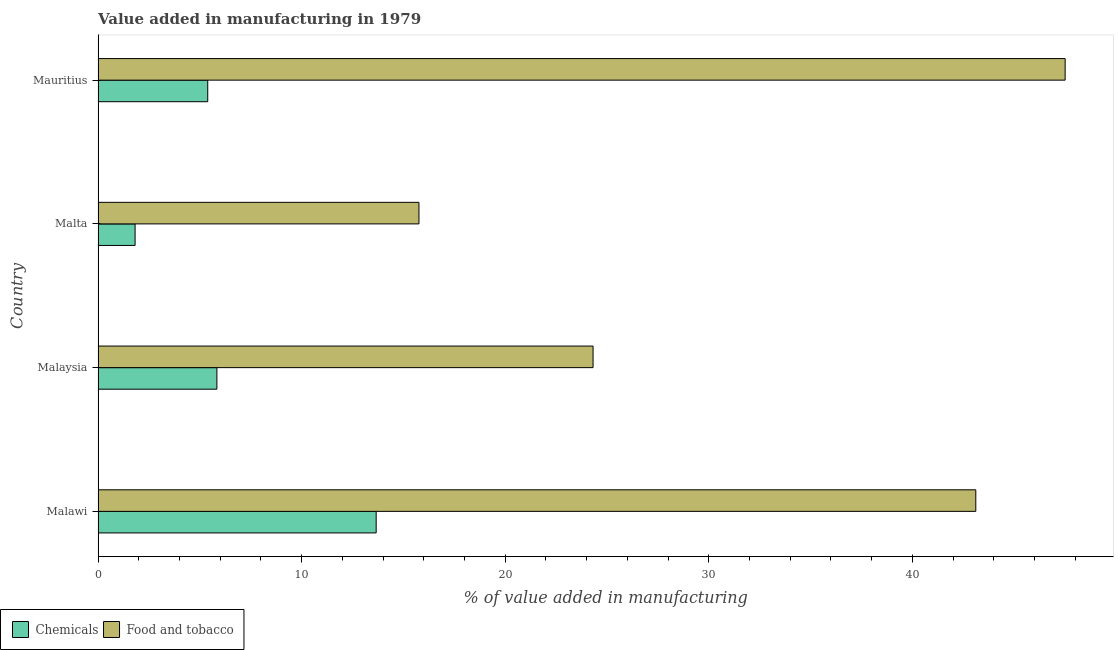How many groups of bars are there?
Make the answer very short. 4. What is the label of the 1st group of bars from the top?
Your answer should be very brief. Mauritius. In how many cases, is the number of bars for a given country not equal to the number of legend labels?
Make the answer very short. 0. What is the value added by  manufacturing chemicals in Malawi?
Provide a short and direct response. 13.66. Across all countries, what is the maximum value added by  manufacturing chemicals?
Offer a terse response. 13.66. Across all countries, what is the minimum value added by  manufacturing chemicals?
Make the answer very short. 1.82. In which country was the value added by  manufacturing chemicals maximum?
Keep it short and to the point. Malawi. In which country was the value added by manufacturing food and tobacco minimum?
Your response must be concise. Malta. What is the total value added by  manufacturing chemicals in the graph?
Offer a very short reply. 26.71. What is the difference between the value added by manufacturing food and tobacco in Malta and that in Mauritius?
Offer a very short reply. -31.74. What is the difference between the value added by manufacturing food and tobacco in Malta and the value added by  manufacturing chemicals in Mauritius?
Offer a terse response. 10.38. What is the average value added by manufacturing food and tobacco per country?
Give a very brief answer. 32.67. What is the difference between the value added by  manufacturing chemicals and value added by manufacturing food and tobacco in Malta?
Provide a succinct answer. -13.94. What is the ratio of the value added by manufacturing food and tobacco in Malaysia to that in Malta?
Keep it short and to the point. 1.54. What is the difference between the highest and the second highest value added by manufacturing food and tobacco?
Offer a very short reply. 4.39. What is the difference between the highest and the lowest value added by  manufacturing chemicals?
Offer a very short reply. 11.84. In how many countries, is the value added by manufacturing food and tobacco greater than the average value added by manufacturing food and tobacco taken over all countries?
Your answer should be very brief. 2. What does the 2nd bar from the top in Malta represents?
Your response must be concise. Chemicals. What does the 2nd bar from the bottom in Malawi represents?
Give a very brief answer. Food and tobacco. How many bars are there?
Your answer should be compact. 8. What is the difference between two consecutive major ticks on the X-axis?
Your response must be concise. 10. Does the graph contain any zero values?
Offer a terse response. No. Does the graph contain grids?
Make the answer very short. No. How are the legend labels stacked?
Provide a short and direct response. Horizontal. What is the title of the graph?
Keep it short and to the point. Value added in manufacturing in 1979. Does "Young" appear as one of the legend labels in the graph?
Your answer should be very brief. No. What is the label or title of the X-axis?
Your answer should be compact. % of value added in manufacturing. What is the label or title of the Y-axis?
Your response must be concise. Country. What is the % of value added in manufacturing of Chemicals in Malawi?
Your answer should be very brief. 13.66. What is the % of value added in manufacturing in Food and tobacco in Malawi?
Provide a short and direct response. 43.12. What is the % of value added in manufacturing of Chemicals in Malaysia?
Keep it short and to the point. 5.84. What is the % of value added in manufacturing in Food and tobacco in Malaysia?
Give a very brief answer. 24.32. What is the % of value added in manufacturing in Chemicals in Malta?
Your response must be concise. 1.82. What is the % of value added in manufacturing of Food and tobacco in Malta?
Your answer should be compact. 15.76. What is the % of value added in manufacturing in Chemicals in Mauritius?
Your response must be concise. 5.39. What is the % of value added in manufacturing of Food and tobacco in Mauritius?
Your answer should be compact. 47.5. Across all countries, what is the maximum % of value added in manufacturing in Chemicals?
Offer a very short reply. 13.66. Across all countries, what is the maximum % of value added in manufacturing of Food and tobacco?
Your response must be concise. 47.5. Across all countries, what is the minimum % of value added in manufacturing in Chemicals?
Ensure brevity in your answer.  1.82. Across all countries, what is the minimum % of value added in manufacturing of Food and tobacco?
Your answer should be very brief. 15.76. What is the total % of value added in manufacturing of Chemicals in the graph?
Your answer should be compact. 26.71. What is the total % of value added in manufacturing in Food and tobacco in the graph?
Provide a succinct answer. 130.7. What is the difference between the % of value added in manufacturing in Chemicals in Malawi and that in Malaysia?
Provide a short and direct response. 7.82. What is the difference between the % of value added in manufacturing of Food and tobacco in Malawi and that in Malaysia?
Keep it short and to the point. 18.8. What is the difference between the % of value added in manufacturing of Chemicals in Malawi and that in Malta?
Offer a terse response. 11.84. What is the difference between the % of value added in manufacturing of Food and tobacco in Malawi and that in Malta?
Provide a succinct answer. 27.35. What is the difference between the % of value added in manufacturing of Chemicals in Malawi and that in Mauritius?
Give a very brief answer. 8.27. What is the difference between the % of value added in manufacturing in Food and tobacco in Malawi and that in Mauritius?
Your answer should be compact. -4.39. What is the difference between the % of value added in manufacturing in Chemicals in Malaysia and that in Malta?
Give a very brief answer. 4.02. What is the difference between the % of value added in manufacturing in Food and tobacco in Malaysia and that in Malta?
Provide a succinct answer. 8.55. What is the difference between the % of value added in manufacturing of Chemicals in Malaysia and that in Mauritius?
Make the answer very short. 0.45. What is the difference between the % of value added in manufacturing of Food and tobacco in Malaysia and that in Mauritius?
Ensure brevity in your answer.  -23.19. What is the difference between the % of value added in manufacturing of Chemicals in Malta and that in Mauritius?
Make the answer very short. -3.57. What is the difference between the % of value added in manufacturing in Food and tobacco in Malta and that in Mauritius?
Offer a very short reply. -31.74. What is the difference between the % of value added in manufacturing in Chemicals in Malawi and the % of value added in manufacturing in Food and tobacco in Malaysia?
Offer a very short reply. -10.65. What is the difference between the % of value added in manufacturing in Chemicals in Malawi and the % of value added in manufacturing in Food and tobacco in Malta?
Your answer should be very brief. -2.1. What is the difference between the % of value added in manufacturing in Chemicals in Malawi and the % of value added in manufacturing in Food and tobacco in Mauritius?
Your answer should be very brief. -33.84. What is the difference between the % of value added in manufacturing in Chemicals in Malaysia and the % of value added in manufacturing in Food and tobacco in Malta?
Your response must be concise. -9.93. What is the difference between the % of value added in manufacturing of Chemicals in Malaysia and the % of value added in manufacturing of Food and tobacco in Mauritius?
Provide a succinct answer. -41.67. What is the difference between the % of value added in manufacturing of Chemicals in Malta and the % of value added in manufacturing of Food and tobacco in Mauritius?
Keep it short and to the point. -45.68. What is the average % of value added in manufacturing in Chemicals per country?
Keep it short and to the point. 6.68. What is the average % of value added in manufacturing in Food and tobacco per country?
Give a very brief answer. 32.67. What is the difference between the % of value added in manufacturing of Chemicals and % of value added in manufacturing of Food and tobacco in Malawi?
Make the answer very short. -29.45. What is the difference between the % of value added in manufacturing of Chemicals and % of value added in manufacturing of Food and tobacco in Malaysia?
Your response must be concise. -18.48. What is the difference between the % of value added in manufacturing in Chemicals and % of value added in manufacturing in Food and tobacco in Malta?
Offer a very short reply. -13.94. What is the difference between the % of value added in manufacturing in Chemicals and % of value added in manufacturing in Food and tobacco in Mauritius?
Keep it short and to the point. -42.12. What is the ratio of the % of value added in manufacturing of Chemicals in Malawi to that in Malaysia?
Make the answer very short. 2.34. What is the ratio of the % of value added in manufacturing in Food and tobacco in Malawi to that in Malaysia?
Your answer should be very brief. 1.77. What is the ratio of the % of value added in manufacturing of Chemicals in Malawi to that in Malta?
Ensure brevity in your answer.  7.51. What is the ratio of the % of value added in manufacturing of Food and tobacco in Malawi to that in Malta?
Your answer should be very brief. 2.74. What is the ratio of the % of value added in manufacturing of Chemicals in Malawi to that in Mauritius?
Give a very brief answer. 2.54. What is the ratio of the % of value added in manufacturing of Food and tobacco in Malawi to that in Mauritius?
Offer a terse response. 0.91. What is the ratio of the % of value added in manufacturing of Chemicals in Malaysia to that in Malta?
Offer a very short reply. 3.21. What is the ratio of the % of value added in manufacturing in Food and tobacco in Malaysia to that in Malta?
Offer a terse response. 1.54. What is the ratio of the % of value added in manufacturing in Chemicals in Malaysia to that in Mauritius?
Provide a short and direct response. 1.08. What is the ratio of the % of value added in manufacturing of Food and tobacco in Malaysia to that in Mauritius?
Make the answer very short. 0.51. What is the ratio of the % of value added in manufacturing in Chemicals in Malta to that in Mauritius?
Provide a short and direct response. 0.34. What is the ratio of the % of value added in manufacturing in Food and tobacco in Malta to that in Mauritius?
Offer a terse response. 0.33. What is the difference between the highest and the second highest % of value added in manufacturing in Chemicals?
Give a very brief answer. 7.82. What is the difference between the highest and the second highest % of value added in manufacturing of Food and tobacco?
Ensure brevity in your answer.  4.39. What is the difference between the highest and the lowest % of value added in manufacturing in Chemicals?
Give a very brief answer. 11.84. What is the difference between the highest and the lowest % of value added in manufacturing in Food and tobacco?
Keep it short and to the point. 31.74. 